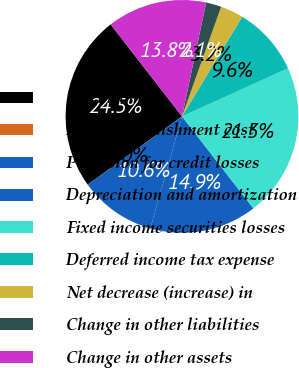Convert chart. <chart><loc_0><loc_0><loc_500><loc_500><pie_chart><fcel>Net income<fcel>Debt extinguishment cost<fcel>Provision for credit losses<fcel>Depreciation and amortization<fcel>Fixed income securities losses<fcel>Deferred income tax expense<fcel>Net decrease (increase) in<fcel>Change in other liabilities<fcel>Change in other assets<nl><fcel>24.46%<fcel>0.0%<fcel>10.64%<fcel>14.89%<fcel>21.27%<fcel>9.58%<fcel>3.19%<fcel>2.13%<fcel>13.83%<nl></chart> 